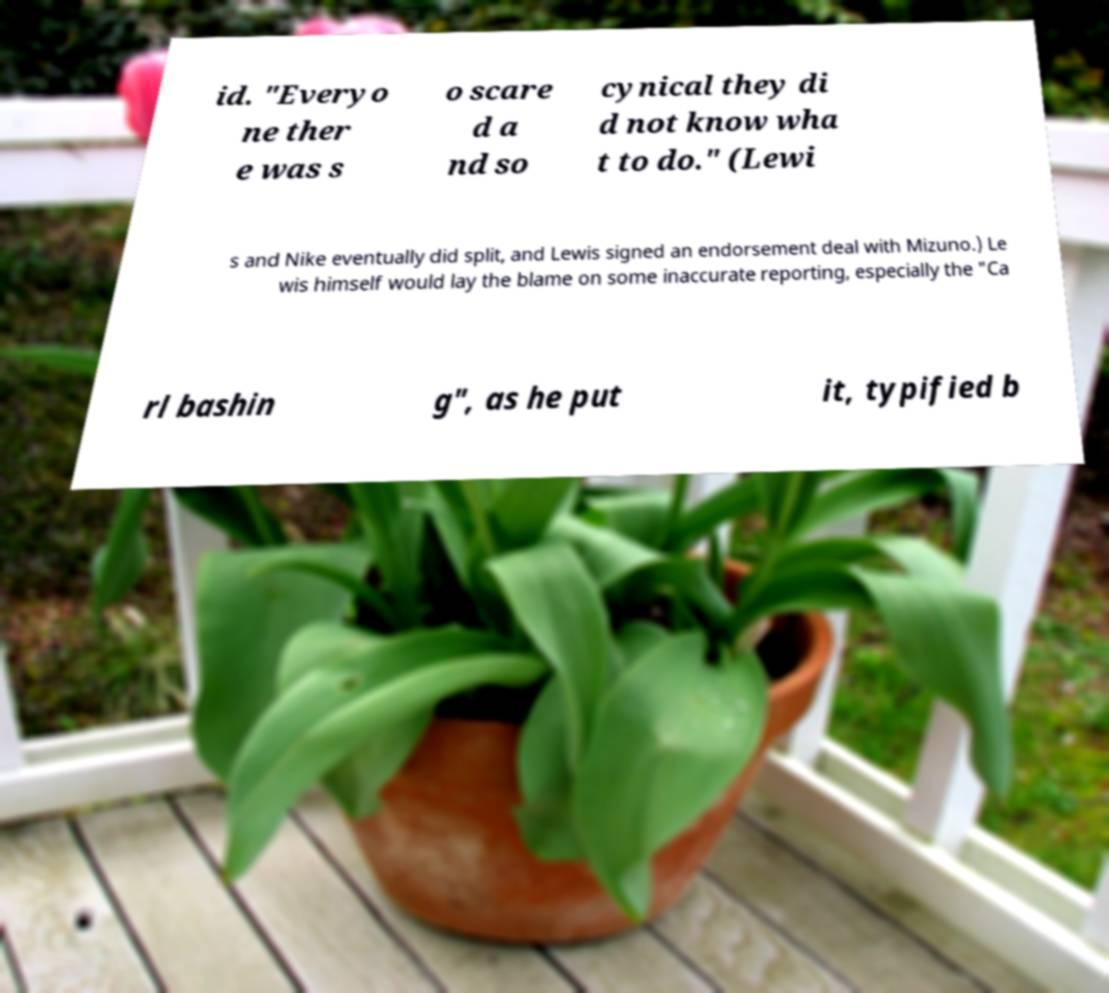There's text embedded in this image that I need extracted. Can you transcribe it verbatim? id. "Everyo ne ther e was s o scare d a nd so cynical they di d not know wha t to do." (Lewi s and Nike eventually did split, and Lewis signed an endorsement deal with Mizuno.) Le wis himself would lay the blame on some inaccurate reporting, especially the "Ca rl bashin g", as he put it, typified b 